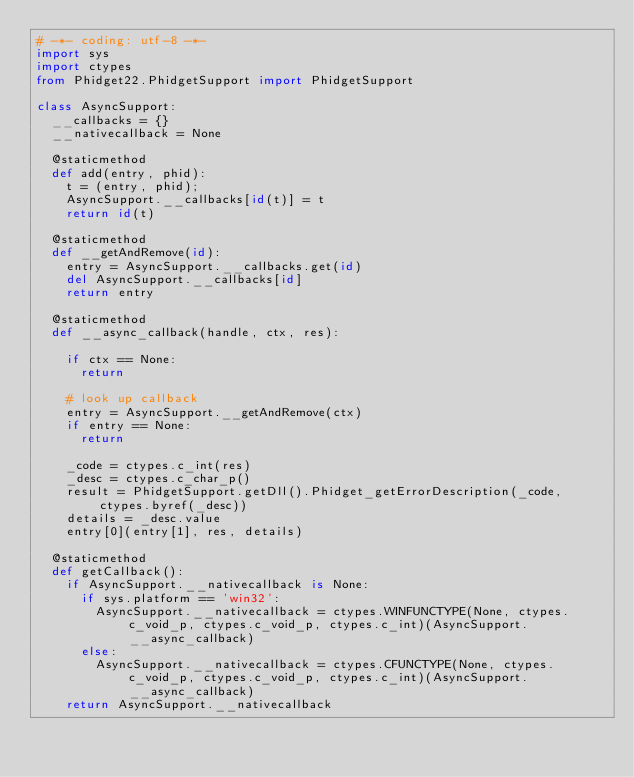<code> <loc_0><loc_0><loc_500><loc_500><_Python_># -*- coding: utf-8 -*-
import sys
import ctypes
from Phidget22.PhidgetSupport import PhidgetSupport

class AsyncSupport:
	__callbacks = {}
	__nativecallback = None

	@staticmethod
	def add(entry, phid):
		t = (entry, phid);
		AsyncSupport.__callbacks[id(t)] = t
		return id(t)

	@staticmethod
	def __getAndRemove(id):
		entry = AsyncSupport.__callbacks.get(id)
		del AsyncSupport.__callbacks[id]
		return entry

	@staticmethod
	def __async_callback(handle, ctx, res):

		if ctx == None:
			return

		# look up callback
		entry = AsyncSupport.__getAndRemove(ctx)
		if entry == None:
			return

		_code = ctypes.c_int(res)
		_desc = ctypes.c_char_p()
		result = PhidgetSupport.getDll().Phidget_getErrorDescription(_code, ctypes.byref(_desc))
		details = _desc.value
		entry[0](entry[1], res, details)

	@staticmethod
	def getCallback():
		if AsyncSupport.__nativecallback is None:
			if sys.platform == 'win32':
				AsyncSupport.__nativecallback = ctypes.WINFUNCTYPE(None, ctypes.c_void_p, ctypes.c_void_p, ctypes.c_int)(AsyncSupport.__async_callback)
			else:
				AsyncSupport.__nativecallback = ctypes.CFUNCTYPE(None, ctypes.c_void_p, ctypes.c_void_p, ctypes.c_int)(AsyncSupport.__async_callback)
		return AsyncSupport.__nativecallback</code> 